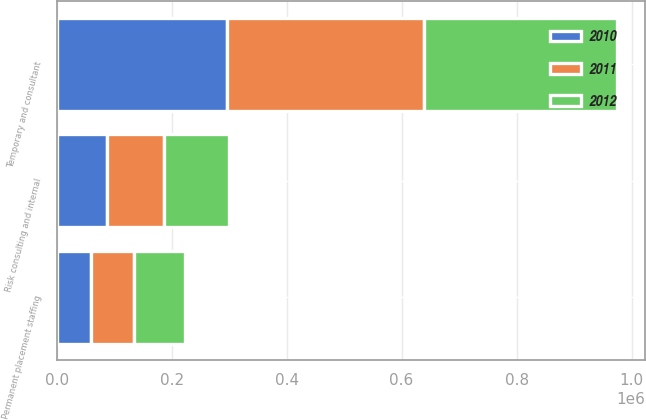Convert chart to OTSL. <chart><loc_0><loc_0><loc_500><loc_500><stacked_bar_chart><ecel><fcel>Temporary and consultant<fcel>Permanent placement staffing<fcel>Risk consulting and internal<nl><fcel>2012<fcel>336468<fcel>88436<fcel>112800<nl><fcel>2011<fcel>342122<fcel>75333<fcel>98499<nl><fcel>2010<fcel>296722<fcel>59952<fcel>88070<nl></chart> 